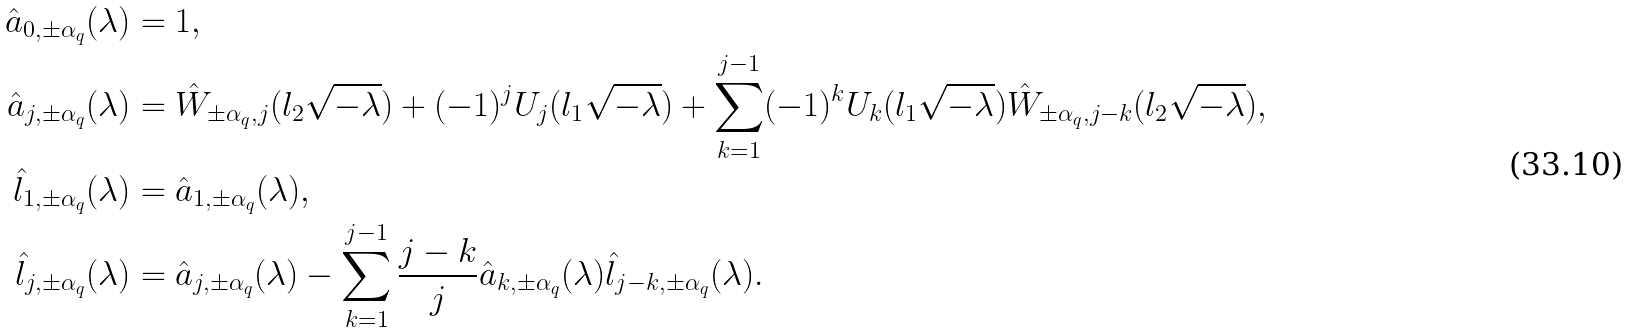<formula> <loc_0><loc_0><loc_500><loc_500>\hat { a } _ { 0 , \pm \alpha _ { q } } ( \lambda ) & = 1 , \\ \hat { a } _ { j , \pm \alpha _ { q } } ( \lambda ) & = \hat { W } _ { \pm \alpha _ { q } , j } ( l _ { 2 } \sqrt { - \lambda } ) + ( - 1 ) ^ { j } U _ { j } ( l _ { 1 } \sqrt { - \lambda } ) + \sum _ { k = 1 } ^ { j - 1 } ( - 1 ) ^ { k } U _ { k } ( l _ { 1 } \sqrt { - \lambda } ) \hat { W } _ { \pm \alpha _ { q } , j - k } ( l _ { 2 } \sqrt { - \lambda } ) , \\ \hat { l } _ { 1 , \pm \alpha _ { q } } ( \lambda ) & = \hat { a } _ { 1 , \pm \alpha _ { q } } ( \lambda ) , \\ \hat { l } _ { j , \pm \alpha _ { q } } ( \lambda ) & = \hat { a } _ { j , \pm \alpha _ { q } } ( \lambda ) - \sum _ { k = 1 } ^ { j - 1 } \frac { j - k } { j } \hat { a } _ { k , \pm \alpha _ { q } } ( \lambda ) \hat { l } _ { j - k , \pm \alpha _ { q } } ( \lambda ) .</formula> 